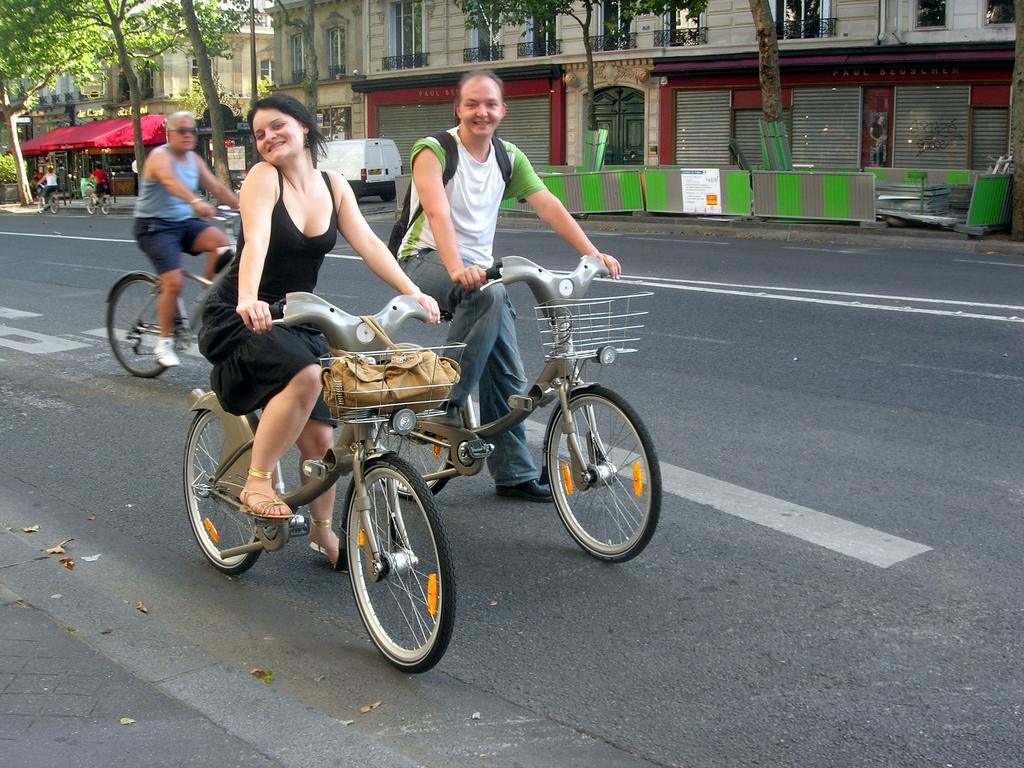Can you describe this image briefly? In this image we can see a five persons riding bicycle on the road. In the background we can see a car, a house and trees. 